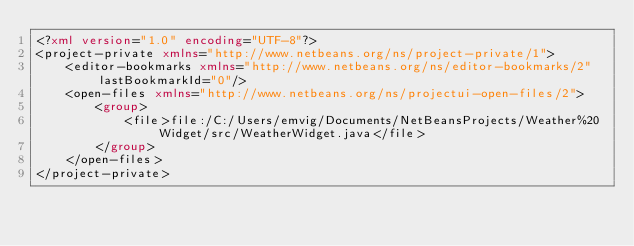Convert code to text. <code><loc_0><loc_0><loc_500><loc_500><_XML_><?xml version="1.0" encoding="UTF-8"?>
<project-private xmlns="http://www.netbeans.org/ns/project-private/1">
    <editor-bookmarks xmlns="http://www.netbeans.org/ns/editor-bookmarks/2" lastBookmarkId="0"/>
    <open-files xmlns="http://www.netbeans.org/ns/projectui-open-files/2">
        <group>
            <file>file:/C:/Users/emvig/Documents/NetBeansProjects/Weather%20Widget/src/WeatherWidget.java</file>
        </group>
    </open-files>
</project-private>
</code> 